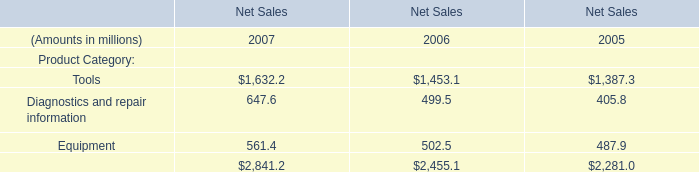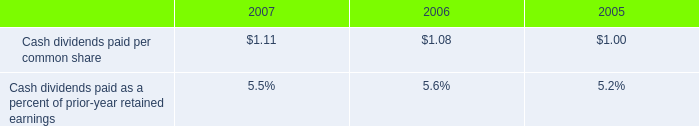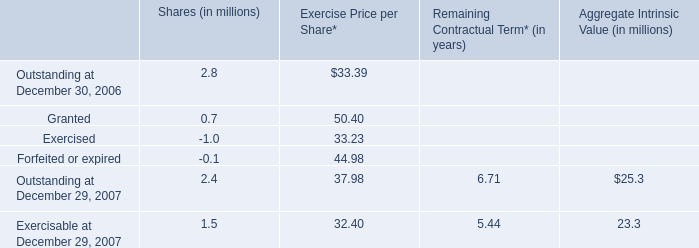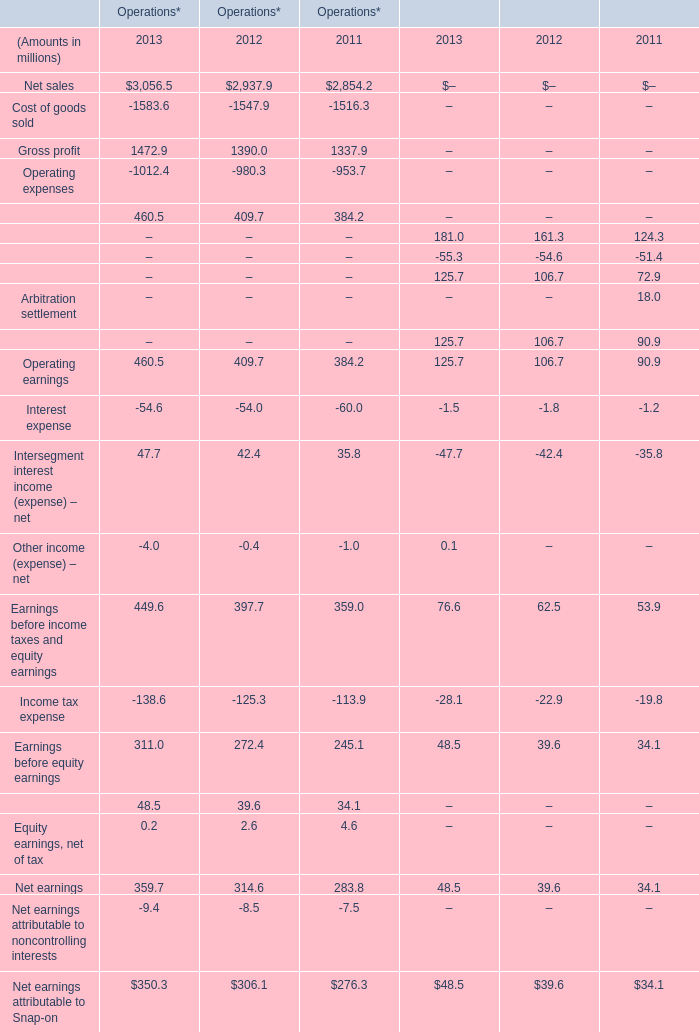based on the cash dividends paid , how many common stock shares were outstanding? 
Computations: ((64.8 - 1000000) / 1.11)
Answer: -900842.52252. 